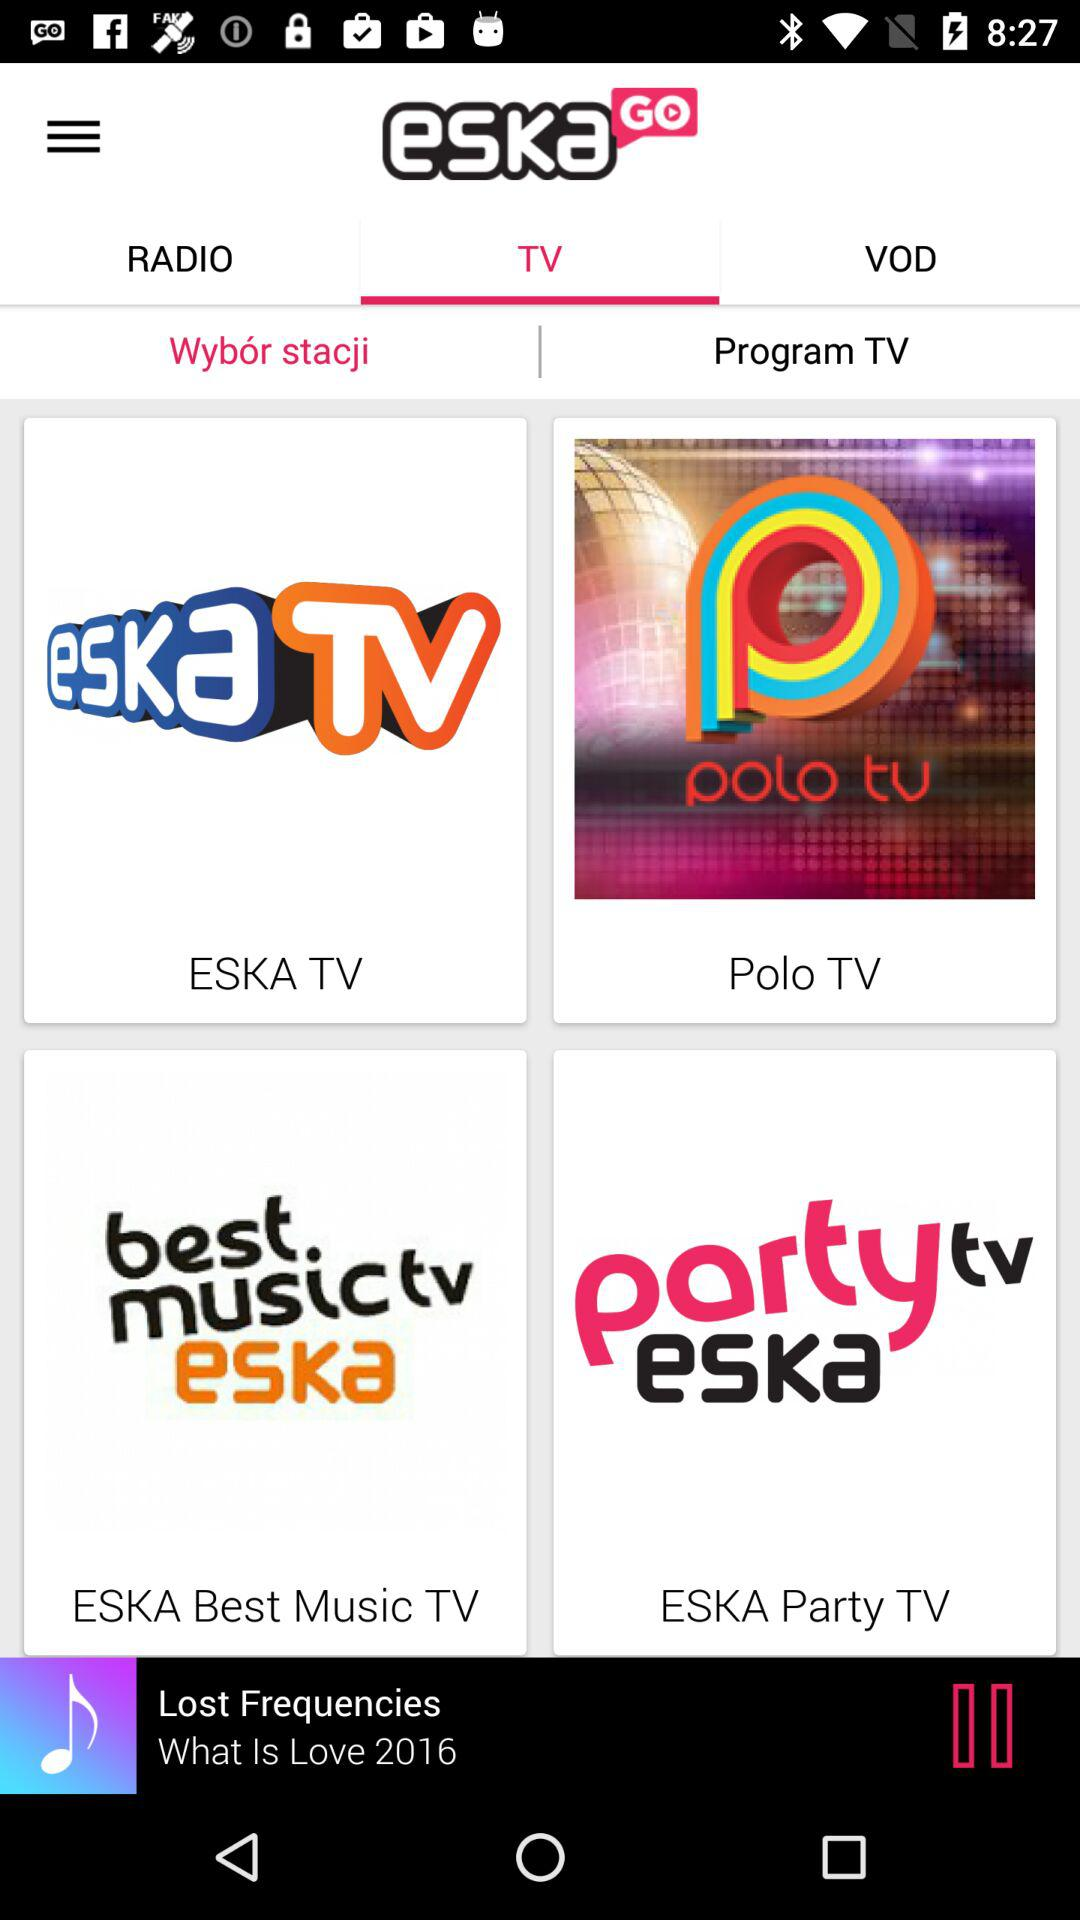Which song is playing? The playing song is "Lost Frequencies". 